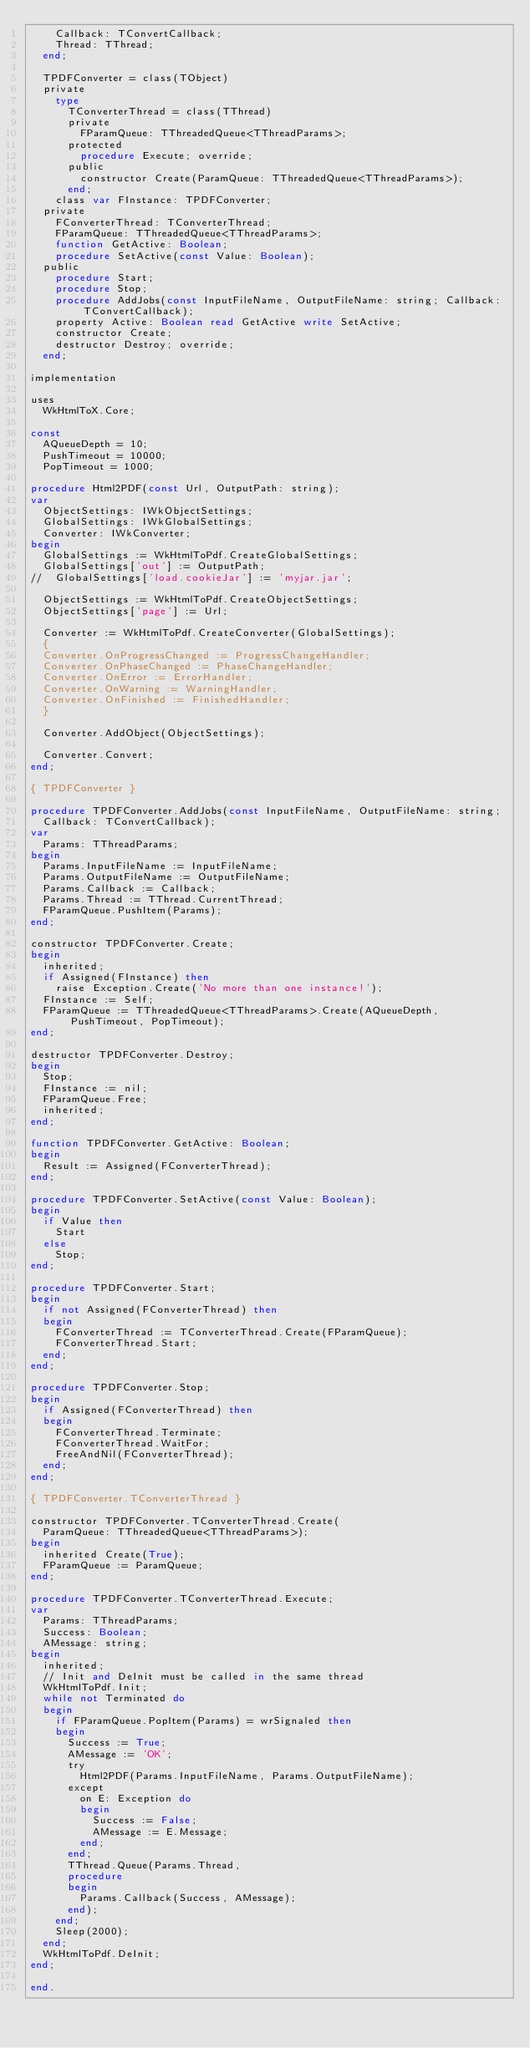Convert code to text. <code><loc_0><loc_0><loc_500><loc_500><_Pascal_>    Callback: TConvertCallback;
    Thread: TThread;
  end;

  TPDFConverter = class(TObject)
  private
    type
      TConverterThread = class(TThread)
      private
        FParamQueue: TThreadedQueue<TThreadParams>;
      protected
        procedure Execute; override;
      public
        constructor Create(ParamQueue: TThreadedQueue<TThreadParams>);
      end;
    class var FInstance: TPDFConverter;
  private
    FConverterThread: TConverterThread;
    FParamQueue: TThreadedQueue<TThreadParams>;
    function GetActive: Boolean;
    procedure SetActive(const Value: Boolean);
  public
    procedure Start;
    procedure Stop;
    procedure AddJobs(const InputFileName, OutputFileName: string; Callback: TConvertCallback);
    property Active: Boolean read GetActive write SetActive;
    constructor Create;
    destructor Destroy; override;
  end;

implementation

uses
  WkHtmlToX.Core;

const
  AQueueDepth = 10;
  PushTimeout = 10000;
  PopTimeout = 1000;

procedure Html2PDF(const Url, OutputPath: string);
var
  ObjectSettings: IWkObjectSettings;
  GlobalSettings: IWkGlobalSettings;
  Converter: IWkConverter;
begin
  GlobalSettings := WkHtmlToPdf.CreateGlobalSettings;
  GlobalSettings['out'] := OutputPath;
//  GlobalSettings['load.cookieJar'] := 'myjar.jar';

  ObjectSettings := WkHtmlToPdf.CreateObjectSettings;
  ObjectSettings['page'] := Url;

  Converter := WkHtmlToPdf.CreateConverter(GlobalSettings);
  {
  Converter.OnProgressChanged := ProgressChangeHandler;
  Converter.OnPhaseChanged := PhaseChangeHandler;
  Converter.OnError := ErrorHandler;
  Converter.OnWarning := WarningHandler;
  Converter.OnFinished := FinishedHandler;
  }

  Converter.AddObject(ObjectSettings);

  Converter.Convert;
end;

{ TPDFConverter }

procedure TPDFConverter.AddJobs(const InputFileName, OutputFileName: string;
  Callback: TConvertCallback);
var
  Params: TThreadParams;
begin
  Params.InputFileName := InputFileName;
  Params.OutputFileName := OutputFileName;
  Params.Callback := Callback;
  Params.Thread := TThread.CurrentThread;
  FParamQueue.PushItem(Params);
end;

constructor TPDFConverter.Create;
begin
  inherited;
  if Assigned(FInstance) then
    raise Exception.Create('No more than one instance!');
  FInstance := Self;
  FParamQueue := TThreadedQueue<TThreadParams>.Create(AQueueDepth, PushTimeout, PopTimeout);
end;

destructor TPDFConverter.Destroy;
begin
  Stop;
  FInstance := nil;
  FParamQueue.Free;
  inherited;
end;

function TPDFConverter.GetActive: Boolean;
begin
  Result := Assigned(FConverterThread);
end;

procedure TPDFConverter.SetActive(const Value: Boolean);
begin
  if Value then
    Start
  else
    Stop;
end;

procedure TPDFConverter.Start;
begin
  if not Assigned(FConverterThread) then
  begin
    FConverterThread := TConverterThread.Create(FParamQueue);
    FConverterThread.Start;
  end;
end;

procedure TPDFConverter.Stop;
begin
  if Assigned(FConverterThread) then
  begin
    FConverterThread.Terminate;
    FConverterThread.WaitFor;
    FreeAndNil(FConverterThread);
  end;
end;

{ TPDFConverter.TConverterThread }

constructor TPDFConverter.TConverterThread.Create(
  ParamQueue: TThreadedQueue<TThreadParams>);
begin
  inherited Create(True);
  FParamQueue := ParamQueue;
end;

procedure TPDFConverter.TConverterThread.Execute;
var
  Params: TThreadParams;
  Success: Boolean;
  AMessage: string;
begin
  inherited;
  // Init and DeInit must be called in the same thread
  WkHtmlToPdf.Init;
  while not Terminated do
  begin
    if FParamQueue.PopItem(Params) = wrSignaled then
    begin
      Success := True;
      AMessage := 'OK';
      try
        Html2PDF(Params.InputFileName, Params.OutputFileName);
      except
        on E: Exception do
        begin
          Success := False;
          AMessage := E.Message;
        end;
      end;
      TThread.Queue(Params.Thread,
      procedure
      begin
        Params.Callback(Success, AMessage);
      end);
    end;
    Sleep(2000);
  end;
  WkHtmlToPdf.DeInit;
end;

end.
</code> 